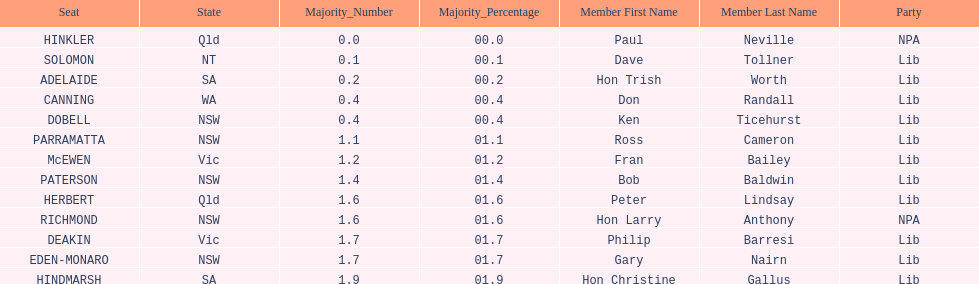Who are all the lib party members? Dave Tollner, Hon Trish Worth, Don Randall, Ken Ticehurst, Ross Cameron, Fran Bailey, Bob Baldwin, Peter Lindsay, Philip Barresi, Gary Nairn, Hon Christine Gallus. What lib party members are in sa? Hon Trish Worth, Hon Christine Gallus. What is the highest difference in majority between members in sa? 01.9. 